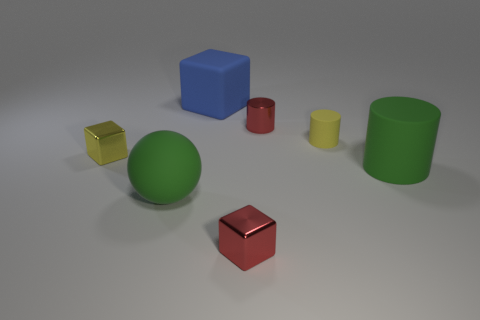Add 2 large red shiny objects. How many objects exist? 9 Subtract all cylinders. How many objects are left? 4 Add 4 large balls. How many large balls exist? 5 Subtract 0 blue spheres. How many objects are left? 7 Subtract all red metallic things. Subtract all tiny things. How many objects are left? 1 Add 7 big rubber cylinders. How many big rubber cylinders are left? 8 